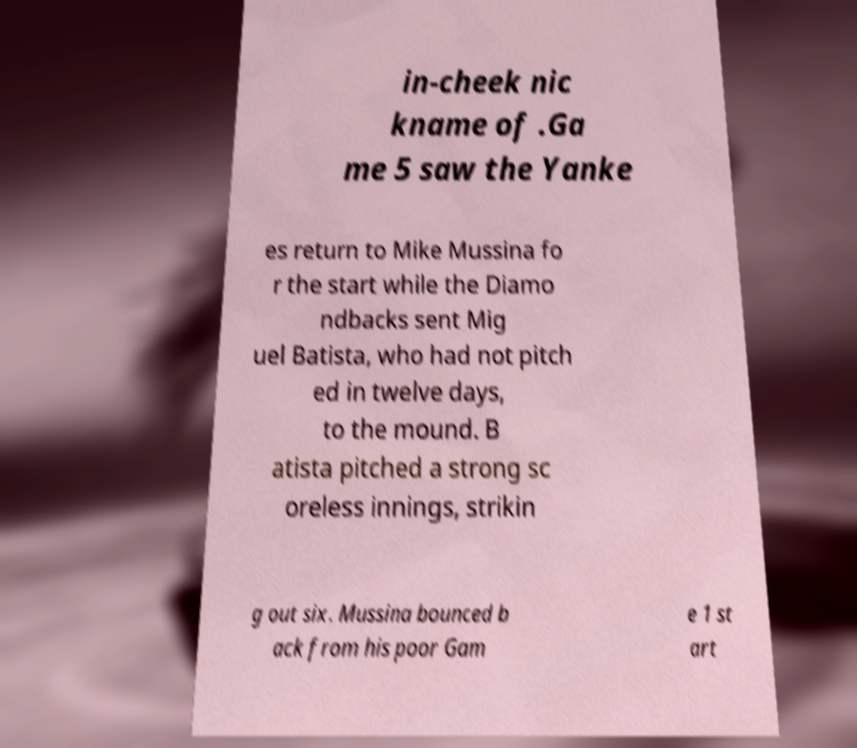Please read and relay the text visible in this image. What does it say? in-cheek nic kname of .Ga me 5 saw the Yanke es return to Mike Mussina fo r the start while the Diamo ndbacks sent Mig uel Batista, who had not pitch ed in twelve days, to the mound. B atista pitched a strong sc oreless innings, strikin g out six. Mussina bounced b ack from his poor Gam e 1 st art 